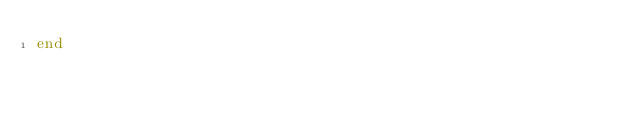Convert code to text. <code><loc_0><loc_0><loc_500><loc_500><_Ruby_>end
</code> 